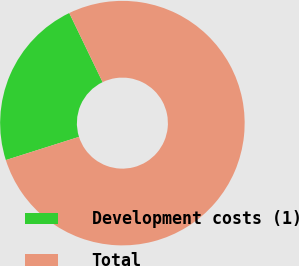Convert chart. <chart><loc_0><loc_0><loc_500><loc_500><pie_chart><fcel>Development costs (1)<fcel>Total<nl><fcel>22.73%<fcel>77.27%<nl></chart> 